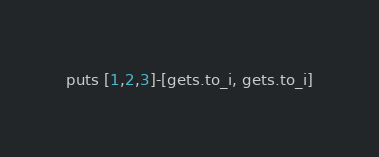<code> <loc_0><loc_0><loc_500><loc_500><_Ruby_>puts [1,2,3]-[gets.to_i, gets.to_i]</code> 